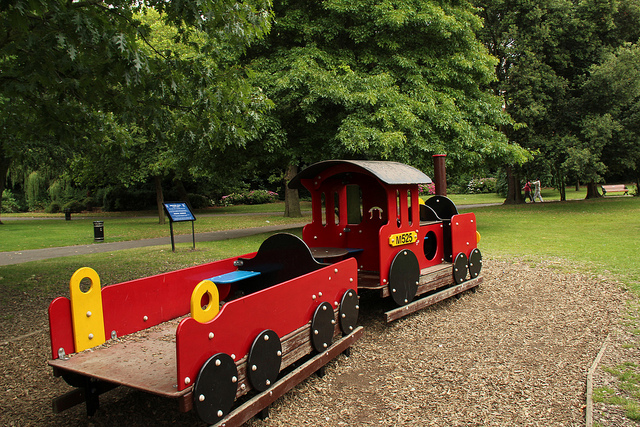<image>What time did the children's park close? I don't know the exact time the children's park closed. It could be 5:00, 6:00 or 9:00 pm. What time did the children's park close? I don't know what time the children's park closed. It can be either 5:00pm, 6:00pm or 9:00pm. 